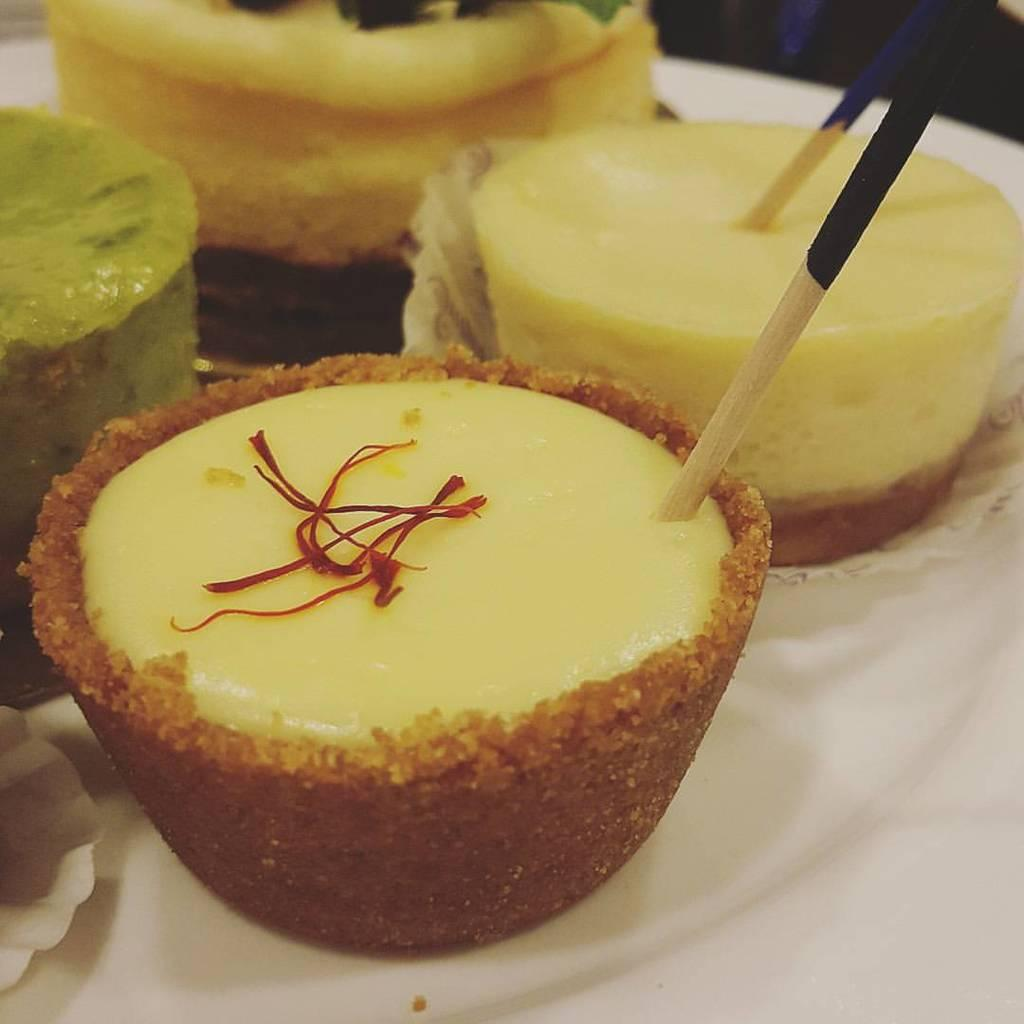What is present in the image related to food? There is food in the image. How are the food items arranged or presented? The food is in plates. What color are the plates that hold the food? The plates are white in color. What type of iron can be seen supporting the plates in the image? There is no iron or any support structure visible in the image; the plates are simply holding the food. 